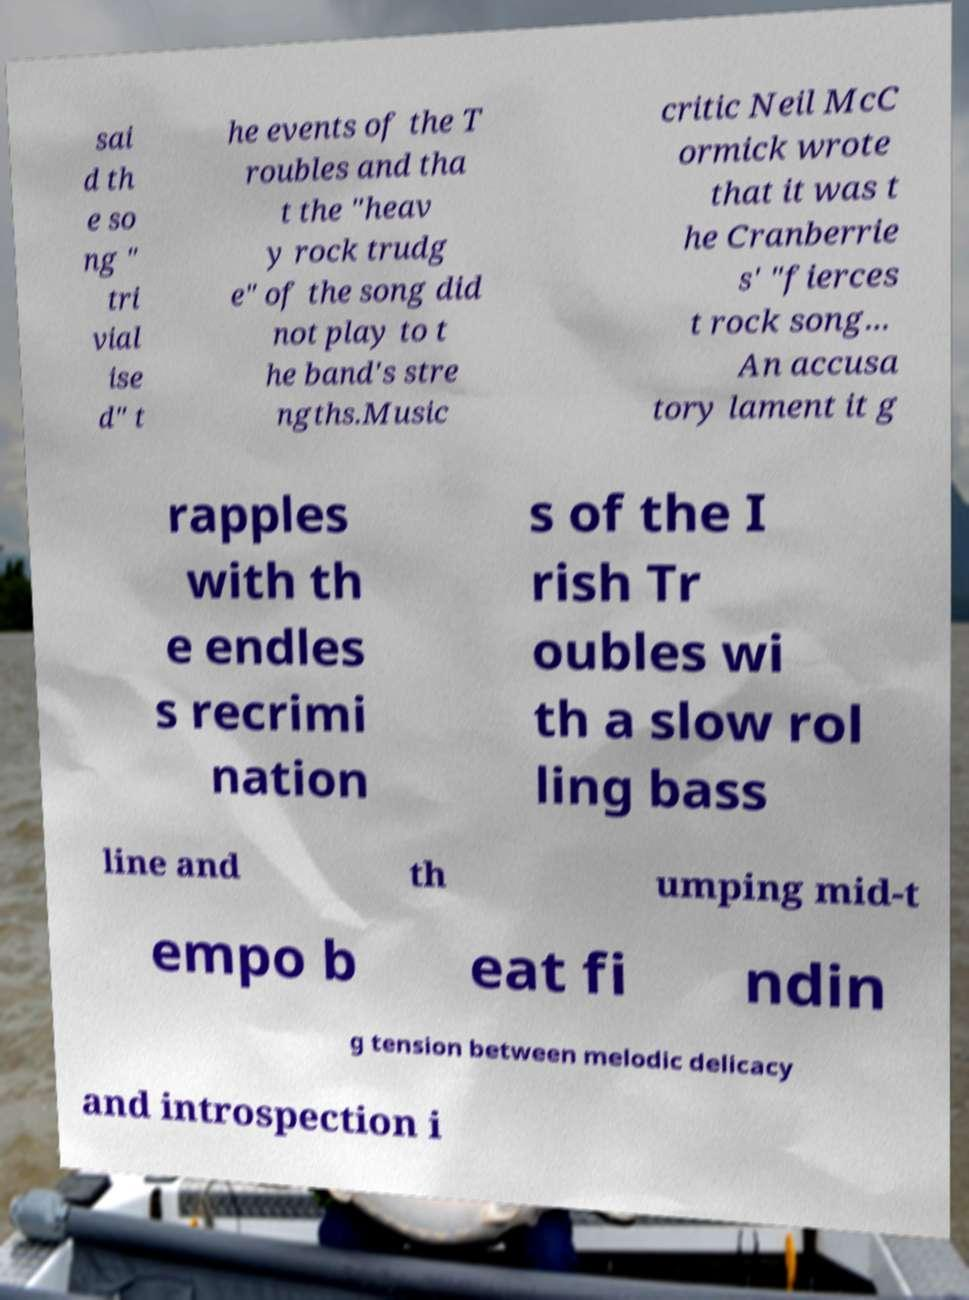Please identify and transcribe the text found in this image. sai d th e so ng " tri vial ise d" t he events of the T roubles and tha t the "heav y rock trudg e" of the song did not play to t he band's stre ngths.Music critic Neil McC ormick wrote that it was t he Cranberrie s' "fierces t rock song... An accusa tory lament it g rapples with th e endles s recrimi nation s of the I rish Tr oubles wi th a slow rol ling bass line and th umping mid-t empo b eat fi ndin g tension between melodic delicacy and introspection i 